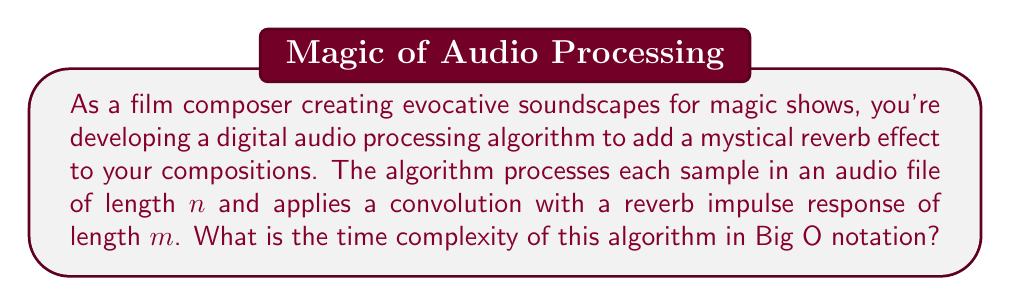What is the answer to this math problem? To analyze the time complexity of this digital audio processing algorithm, we need to consider the operations performed for each sample in the audio file:

1. The audio file has $n$ samples.
2. For each sample, we need to apply convolution with the reverb impulse response of length $m$.
3. Convolution involves multiplying each sample with each element of the impulse response and summing the results.

Let's break down the process:

1. Outer loop: Iterates through all $n$ samples of the audio file.
2. Inner loop: For each sample, performs convolution with $m$ elements of the impulse response.
3. Within the inner loop: Multiplication and addition operations (constant time).

The structure of the algorithm can be represented as:

```
for i = 1 to n:
    for j = 1 to m:
        perform convolution operation
```

The total number of operations is approximately $n * m$.

Therefore, the time complexity of this algorithm is $O(n * m)$.

In the context of audio processing, $m$ (the length of the impulse response) is typically much smaller than $n$ (the length of the audio file) and often considered constant. However, for a rigorous analysis, we keep both variables to show their relationship in the time complexity.
Answer: $O(n * m)$, where $n$ is the length of the audio file and $m$ is the length of the reverb impulse response. 